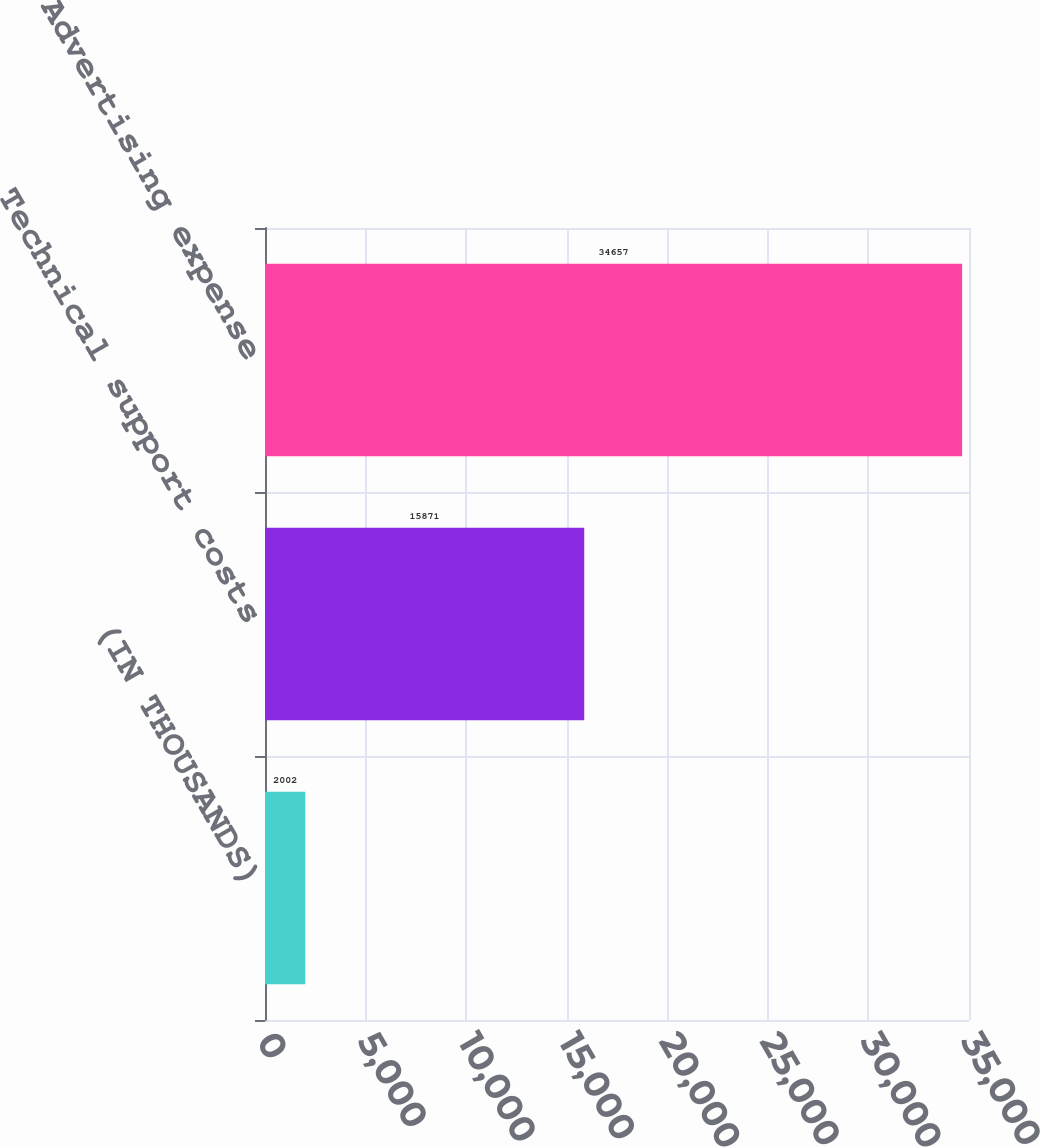Convert chart. <chart><loc_0><loc_0><loc_500><loc_500><bar_chart><fcel>(IN THOUSANDS)<fcel>Technical support costs<fcel>Advertising expense<nl><fcel>2002<fcel>15871<fcel>34657<nl></chart> 